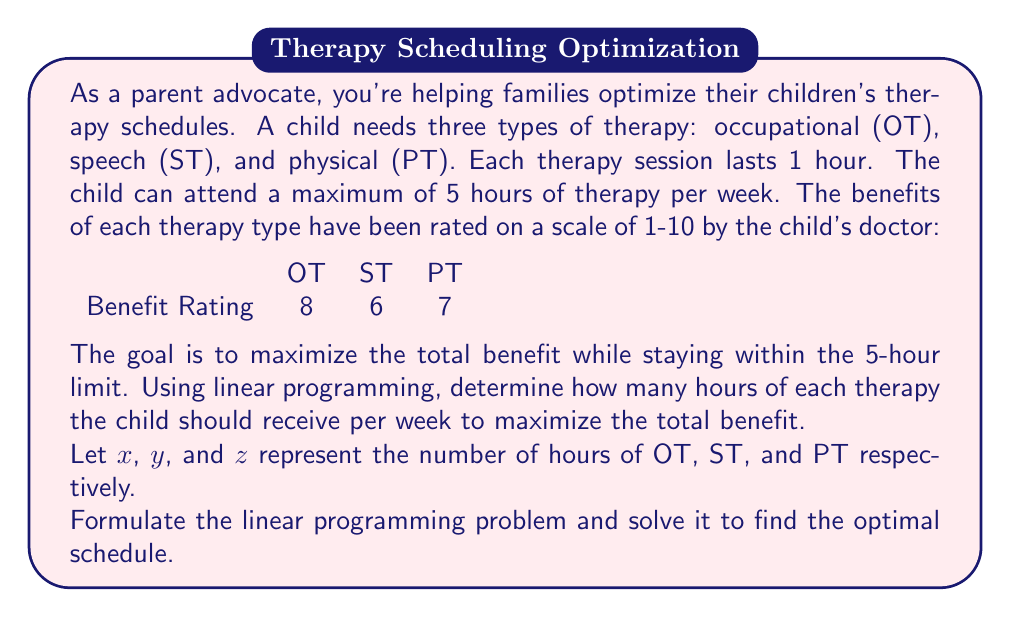What is the answer to this math problem? To solve this problem using linear programming, we need to follow these steps:

1. Define the objective function:
   We want to maximize the total benefit, which is represented by:
   $$8x + 6y + 7z$$

2. Identify the constraints:
   a) Total therapy time: $x + y + z \leq 5$
   b) Non-negativity: $x \geq 0$, $y \geq 0$, $z \geq 0$

3. Set up the linear programming problem:
   Maximize: $8x + 6y + 7z$
   Subject to:
   $x + y + z \leq 5$
   $x, y, z \geq 0$

4. Solve the problem:
   We can solve this using the graphical method or the simplex algorithm. In this case, we'll use the corner point method since we have a simple constraint.

   The corner points of the feasible region are:
   (0, 0, 0), (5, 0, 0), (0, 5, 0), (0, 0, 5)

   Evaluating the objective function at each point:
   (0, 0, 0): $8(0) + 6(0) + 7(0) = 0$
   (5, 0, 0): $8(5) + 6(0) + 7(0) = 40$
   (0, 5, 0): $8(0) + 6(5) + 7(0) = 30$
   (0, 0, 5): $8(0) + 6(0) + 7(5) = 35$

   The maximum value occurs at (5, 0, 0), which corresponds to 5 hours of OT, 0 hours of ST, and 0 hours of PT.

5. Interpret the result:
   The optimal schedule to maximize the total benefit is 5 hours of occupational therapy per week.
Answer: The optimal schedule is 5 hours of occupational therapy (OT) per week, with 0 hours of speech therapy (ST) and 0 hours of physical therapy (PT). This schedule maximizes the total benefit at 40 units. 